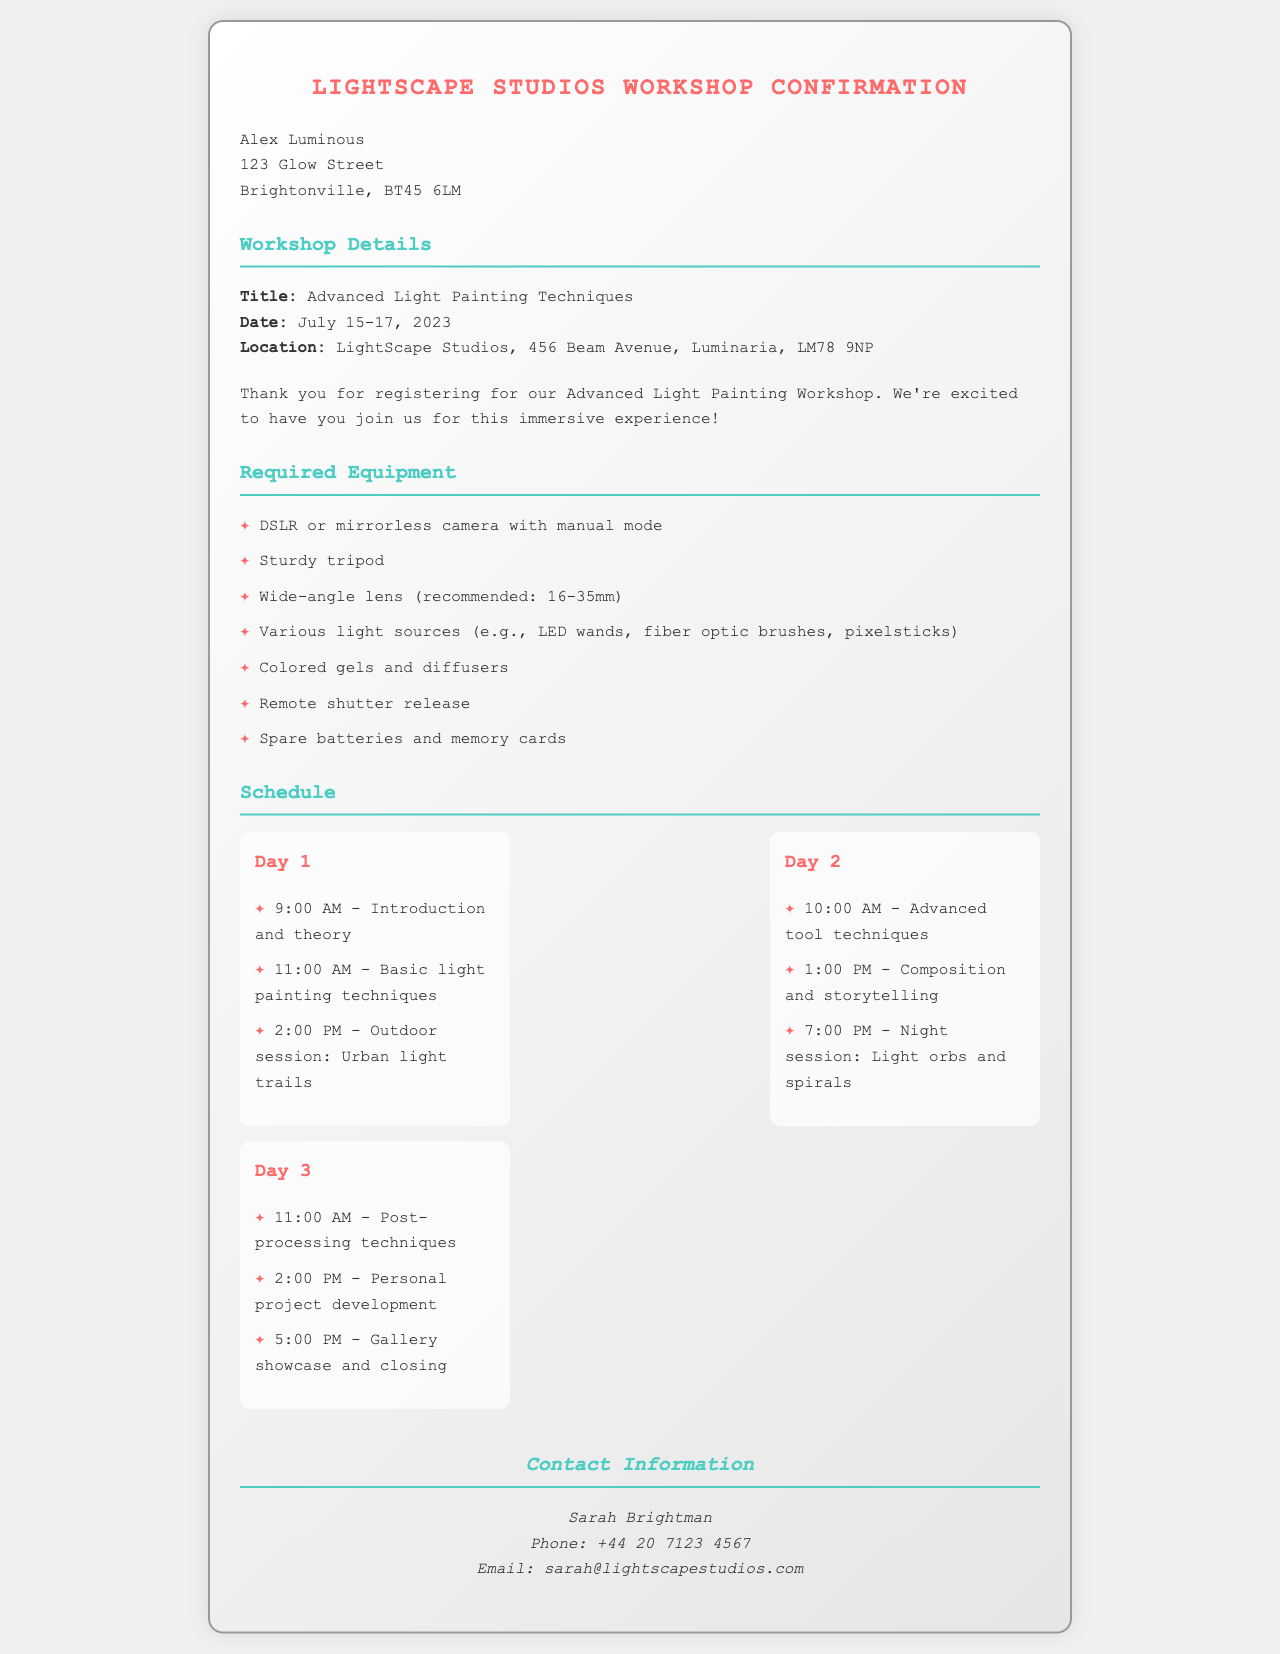what is the workshop title? The workshop title is clearly stated in the document under Workshop Details.
Answer: Advanced Light Painting Techniques what are the dates of the workshop? The dates are specified in the Workshop Details section.
Answer: July 15-17, 2023 who is the contact person for the workshop? The contact person is mentioned in the Contact Information section.
Answer: Sarah Brightman how many days does the workshop span? The span of the workshop can be deduced from the dates provided.
Answer: 3 days what is one of the required equipment items? The required equipment list includes various items for the workshop.
Answer: DSLR or mirrorless camera with manual mode what time does the Introduction and theory session start on Day 1? This information can be found in the schedule for Day 1.
Answer: 9:00 AM what is the location of the workshop? The location is detailed in the Workshop Details section.
Answer: LightScape Studios, 456 Beam Avenue, Luminaria, LM78 9NP what is one of the activities planned for Day 2? A specific activity can be found in the Day 2 schedule.
Answer: Composition and storytelling what item is recommended for Day 1's outdoor session? The outdoor session's details are included in the Day 1 schedule.
Answer: Urban light trails 